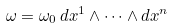<formula> <loc_0><loc_0><loc_500><loc_500>\omega = \omega _ { 0 } \, d x ^ { 1 } \wedge \dots \wedge d x ^ { n }</formula> 